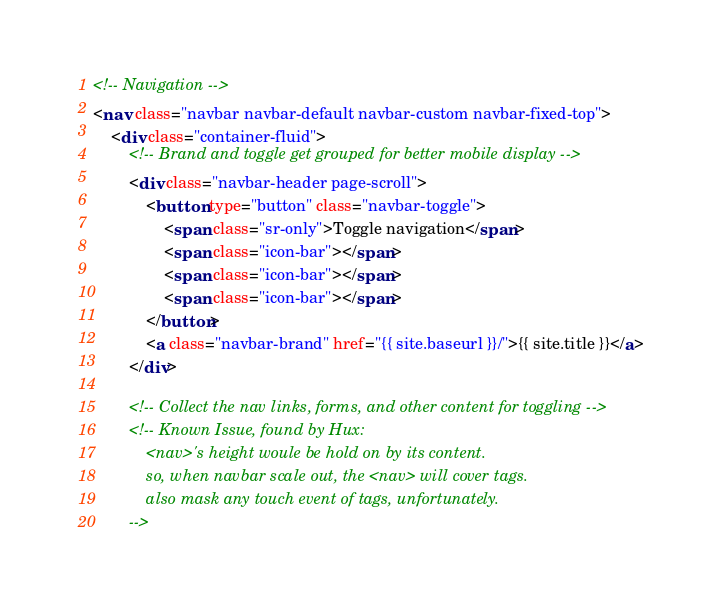<code> <loc_0><loc_0><loc_500><loc_500><_HTML_><!-- Navigation -->
<nav class="navbar navbar-default navbar-custom navbar-fixed-top">
    <div class="container-fluid">
        <!-- Brand and toggle get grouped for better mobile display -->
        <div class="navbar-header page-scroll">
            <button type="button" class="navbar-toggle">
                <span class="sr-only">Toggle navigation</span>
                <span class="icon-bar"></span>
                <span class="icon-bar"></span>
                <span class="icon-bar"></span>
            </button>
            <a class="navbar-brand" href="{{ site.baseurl }}/">{{ site.title }}</a>
        </div>

        <!-- Collect the nav links, forms, and other content for toggling -->
        <!-- Known Issue, found by Hux:
            <nav>'s height woule be hold on by its content.
            so, when navbar scale out, the <nav> will cover tags.
            also mask any touch event of tags, unfortunately.
        --></code> 